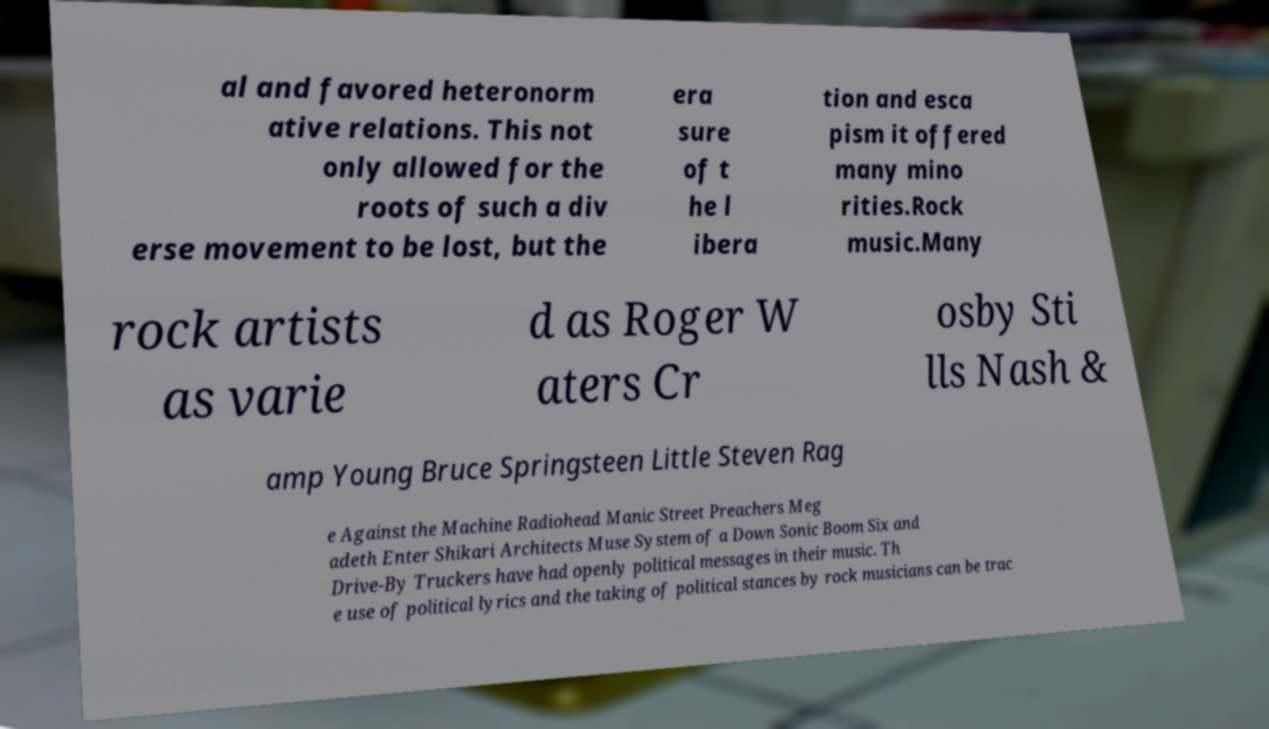What messages or text are displayed in this image? I need them in a readable, typed format. al and favored heteronorm ative relations. This not only allowed for the roots of such a div erse movement to be lost, but the era sure of t he l ibera tion and esca pism it offered many mino rities.Rock music.Many rock artists as varie d as Roger W aters Cr osby Sti lls Nash & amp Young Bruce Springsteen Little Steven Rag e Against the Machine Radiohead Manic Street Preachers Meg adeth Enter Shikari Architects Muse System of a Down Sonic Boom Six and Drive-By Truckers have had openly political messages in their music. Th e use of political lyrics and the taking of political stances by rock musicians can be trac 